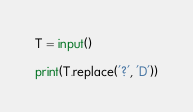Convert code to text. <code><loc_0><loc_0><loc_500><loc_500><_Python_>T = input()

print(T.replace('?', 'D'))</code> 